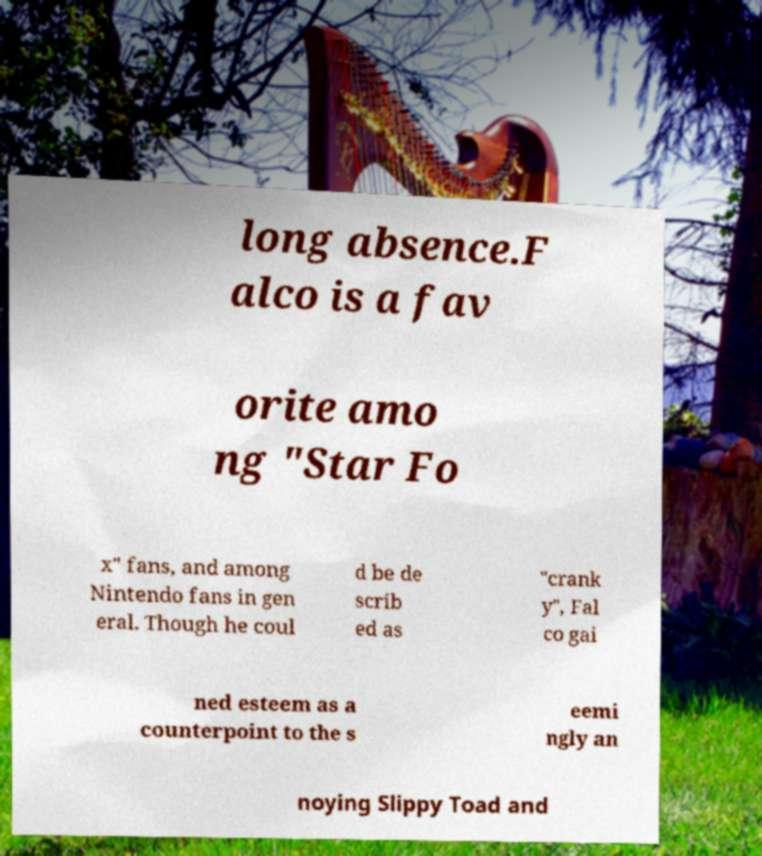Could you extract and type out the text from this image? long absence.F alco is a fav orite amo ng "Star Fo x" fans, and among Nintendo fans in gen eral. Though he coul d be de scrib ed as "crank y", Fal co gai ned esteem as a counterpoint to the s eemi ngly an noying Slippy Toad and 